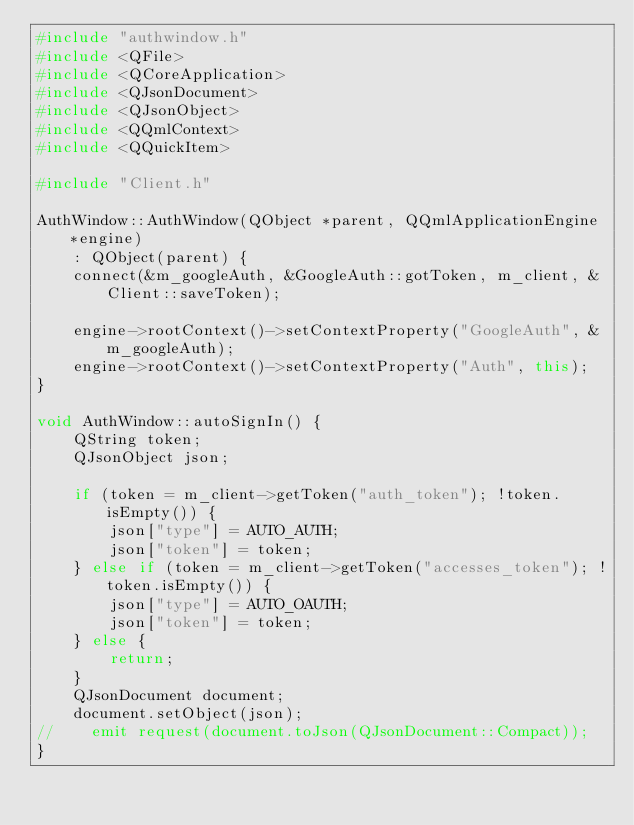Convert code to text. <code><loc_0><loc_0><loc_500><loc_500><_C++_>#include "authwindow.h"
#include <QFile>
#include <QCoreApplication>
#include <QJsonDocument>
#include <QJsonObject>
#include <QQmlContext>
#include <QQuickItem>

#include "Client.h"

AuthWindow::AuthWindow(QObject *parent, QQmlApplicationEngine *engine)
    : QObject(parent) {
    connect(&m_googleAuth, &GoogleAuth::gotToken, m_client, &Client::saveToken);

    engine->rootContext()->setContextProperty("GoogleAuth", &m_googleAuth);
    engine->rootContext()->setContextProperty("Auth", this);
}

void AuthWindow::autoSignIn() {
    QString token;
    QJsonObject json;

    if (token = m_client->getToken("auth_token"); !token.isEmpty()) {
        json["type"] = AUTO_AUTH;
        json["token"] = token;
    } else if (token = m_client->getToken("accesses_token"); !token.isEmpty()) {
        json["type"] = AUTO_OAUTH;
        json["token"] = token;
    } else {
        return;
    }
    QJsonDocument document;
    document.setObject(json);
//    emit request(document.toJson(QJsonDocument::Compact));
}


</code> 